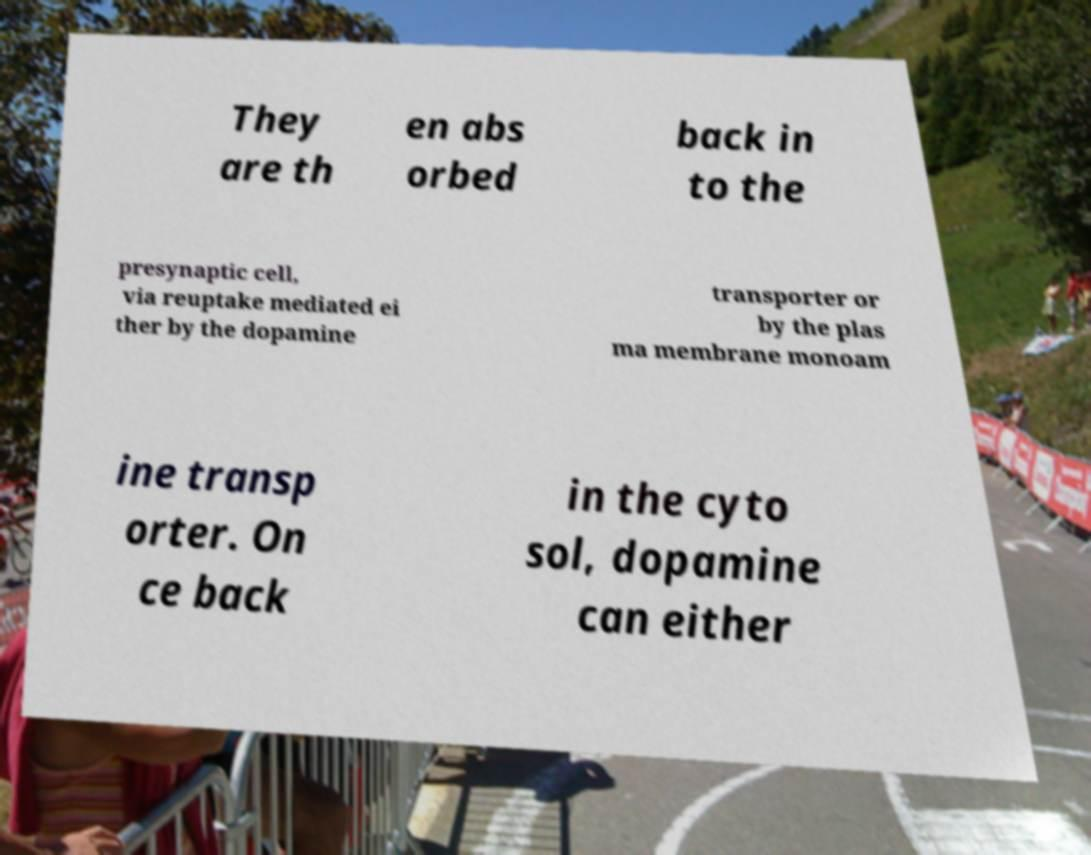Can you read and provide the text displayed in the image?This photo seems to have some interesting text. Can you extract and type it out for me? They are th en abs orbed back in to the presynaptic cell, via reuptake mediated ei ther by the dopamine transporter or by the plas ma membrane monoam ine transp orter. On ce back in the cyto sol, dopamine can either 